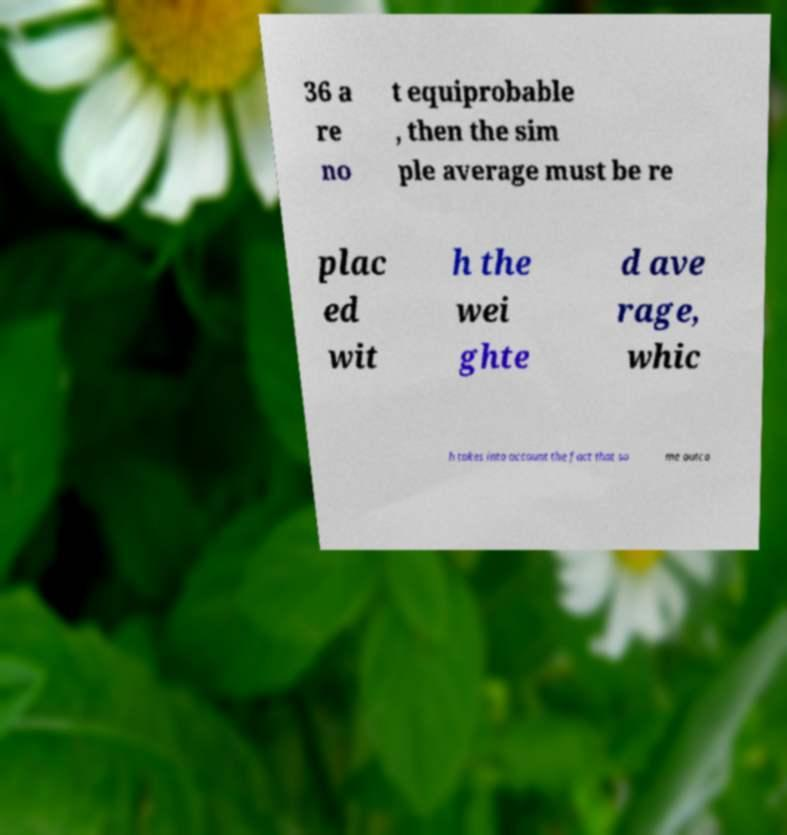Can you read and provide the text displayed in the image?This photo seems to have some interesting text. Can you extract and type it out for me? 36 a re no t equiprobable , then the sim ple average must be re plac ed wit h the wei ghte d ave rage, whic h takes into account the fact that so me outco 